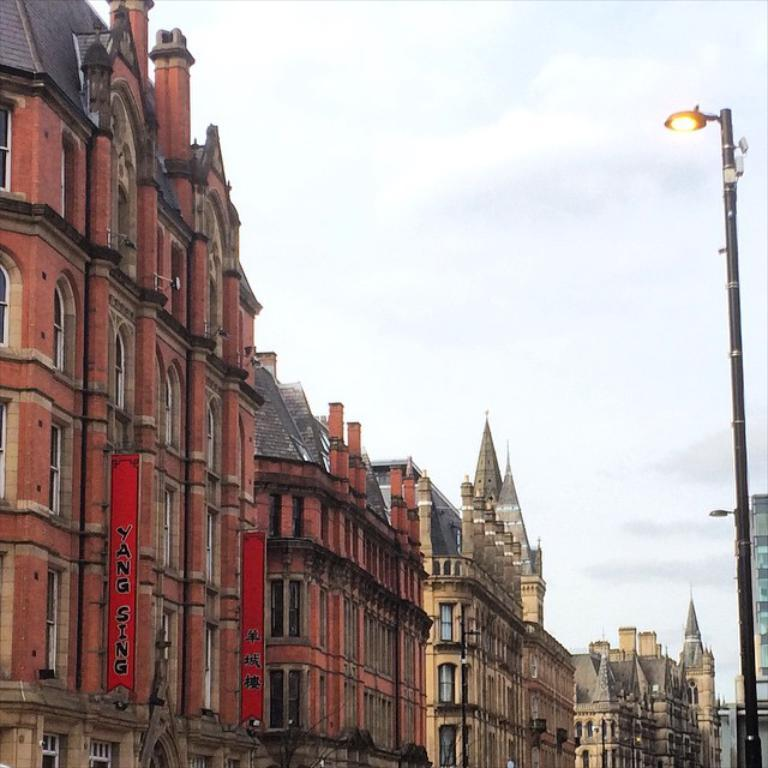What type of structures can be seen in the image? There are buildings in the image. What type of lighting is present in the image? There is a street light in the image. What part of the natural environment is visible in the image? The sky is visible in the image. What can be observed in the sky? Clouds are present in the sky. What type of death is depicted in the image? There is no depiction of death in the image; it features buildings, a street light, the sky, and clouds. 